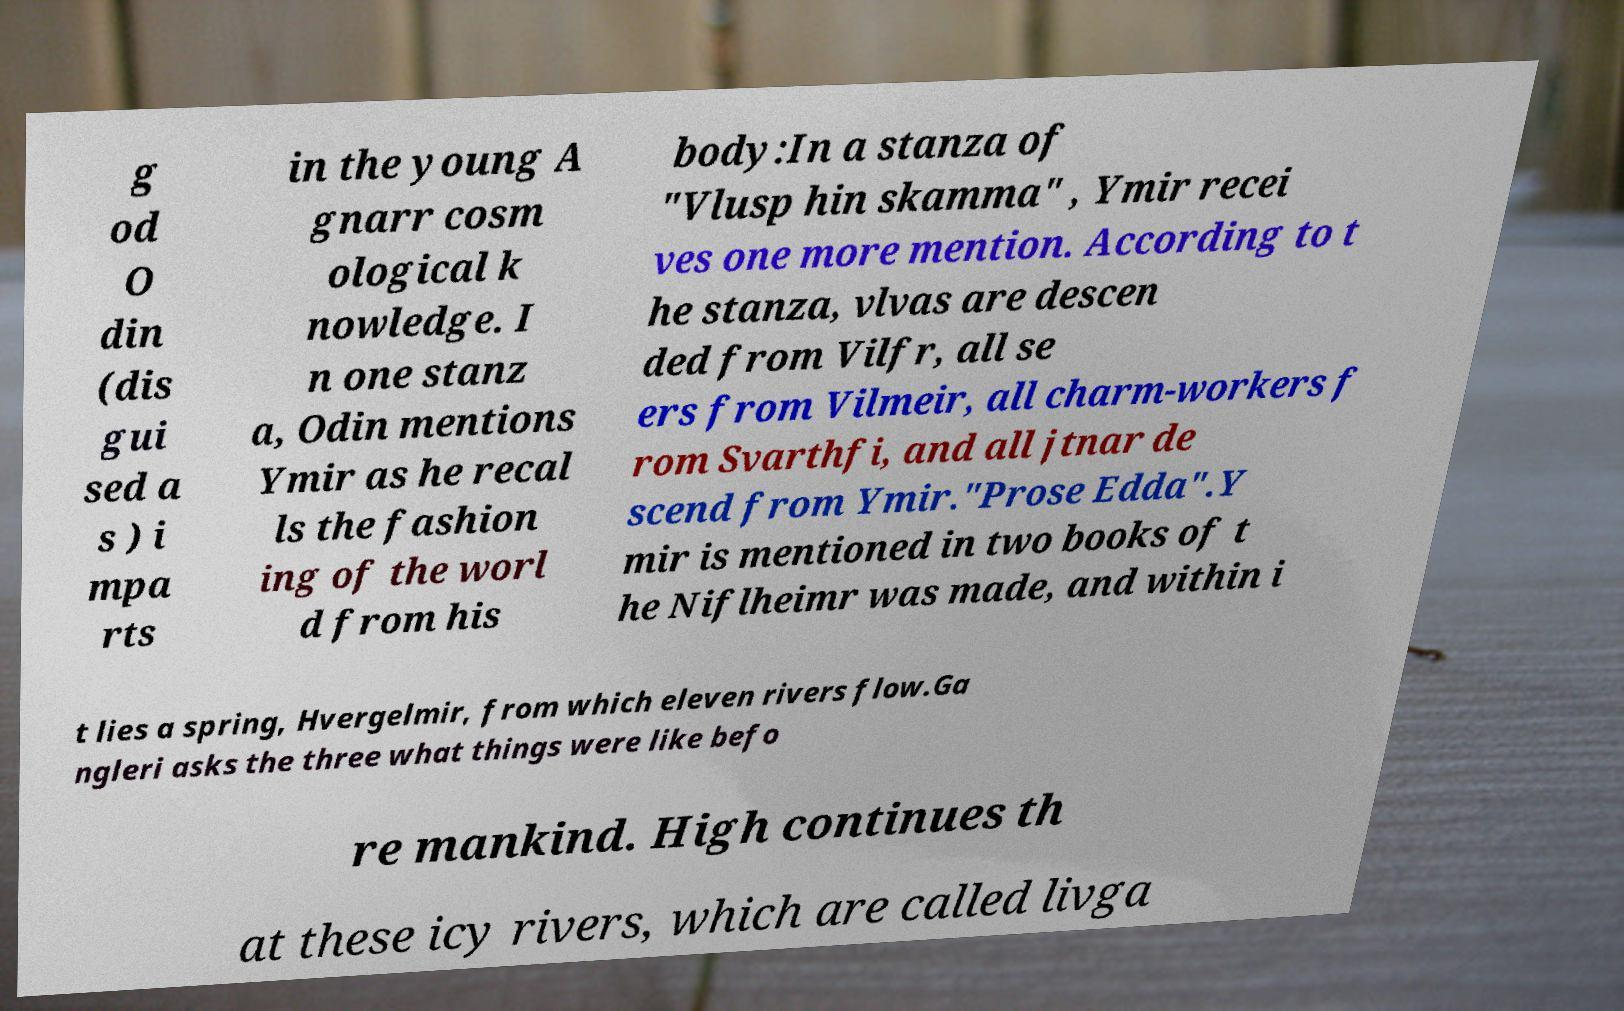For documentation purposes, I need the text within this image transcribed. Could you provide that? g od O din (dis gui sed a s ) i mpa rts in the young A gnarr cosm ological k nowledge. I n one stanz a, Odin mentions Ymir as he recal ls the fashion ing of the worl d from his body:In a stanza of "Vlusp hin skamma" , Ymir recei ves one more mention. According to t he stanza, vlvas are descen ded from Vilfr, all se ers from Vilmeir, all charm-workers f rom Svarthfi, and all jtnar de scend from Ymir."Prose Edda".Y mir is mentioned in two books of t he Niflheimr was made, and within i t lies a spring, Hvergelmir, from which eleven rivers flow.Ga ngleri asks the three what things were like befo re mankind. High continues th at these icy rivers, which are called livga 